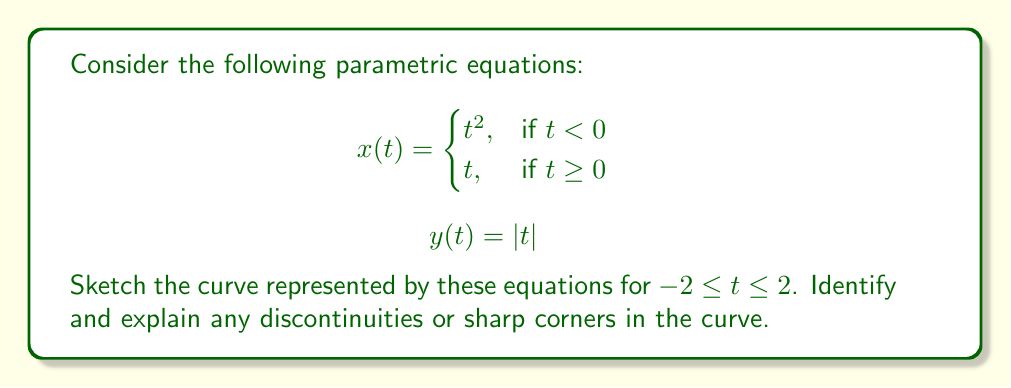Can you solve this math problem? To sketch the curve and identify discontinuities or sharp corners, let's follow these steps:

1) First, let's analyze the equations for $x(t)$ and $y(t)$:

   - $x(t)$ is a piecewise function, changing behavior at $t=0$
   - $y(t)$ is the absolute value function

2) Let's consider the curve in four parts:

   a) For $t < 0$:
      $x = t^2$ and $y = -t$ (since $|t| = -t$ when $t < 0$)
      This forms a parabola in the second quadrant.

   b) For $t = 0$:
      $x = 0$ and $y = 0$
      This is the origin point (0, 0).

   c) For $t > 0$:
      $x = t$ and $y = t$
      This forms a straight line $y = x$ in the first quadrant.

3) Now, let's identify discontinuities or sharp corners:

   - At $t = 0$, there's a sharp corner. This is because:
     - As $t$ approaches 0 from the negative side, the slope of the curve approaches $\infty$
     - As $t$ approaches 0 from the positive side, the slope of the curve is 1
   - This abrupt change in slope creates a sharp corner at the origin.

4) Sketch of the curve:

[asy]
import graph;
size(200);
real f(real x) {return x^2;}
real g(real x) {return x;}
real h(real x) {return abs(x);}

draw(graph(f,-2,0), blue);
draw(graph(g,0,2), blue);
draw(graph(h,-2,2), red);

xaxis("x", arrow=Arrow);
yaxis("y", arrow=Arrow);

label("$t=-2$", (-4,2), W);
label("$t=2$", (2,2), E);
label("Sharp corner at (0,0)", (0,0), SE);
[/asy]

The blue curve represents $x(t)$, and the red curve represents $y(t)$. The parametric curve is where these intersect.
Answer: The curve has a sharp corner at the origin (0, 0) where $t = 0$. It consists of a parabolic segment in the second quadrant for $t < 0$, and a straight line segment in the first quadrant for $t > 0$. There are no discontinuities in the curve. 